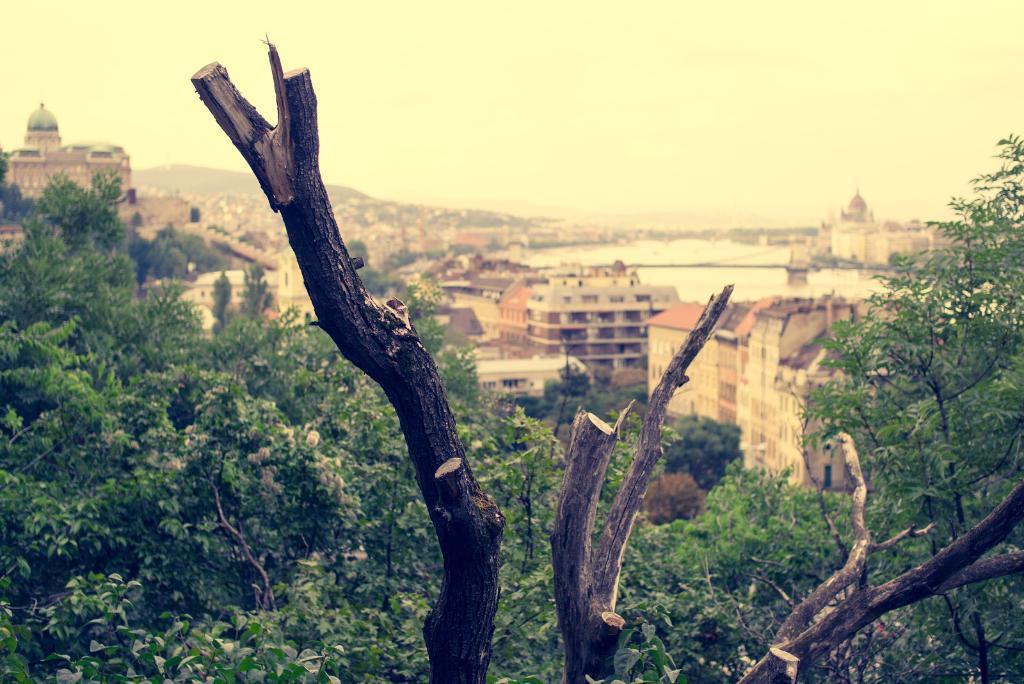Describe this image in one or two sentences. In this image I can see trees and branch. Back Side I can see buildings and water. We can see a fort. The sky is in white color. 